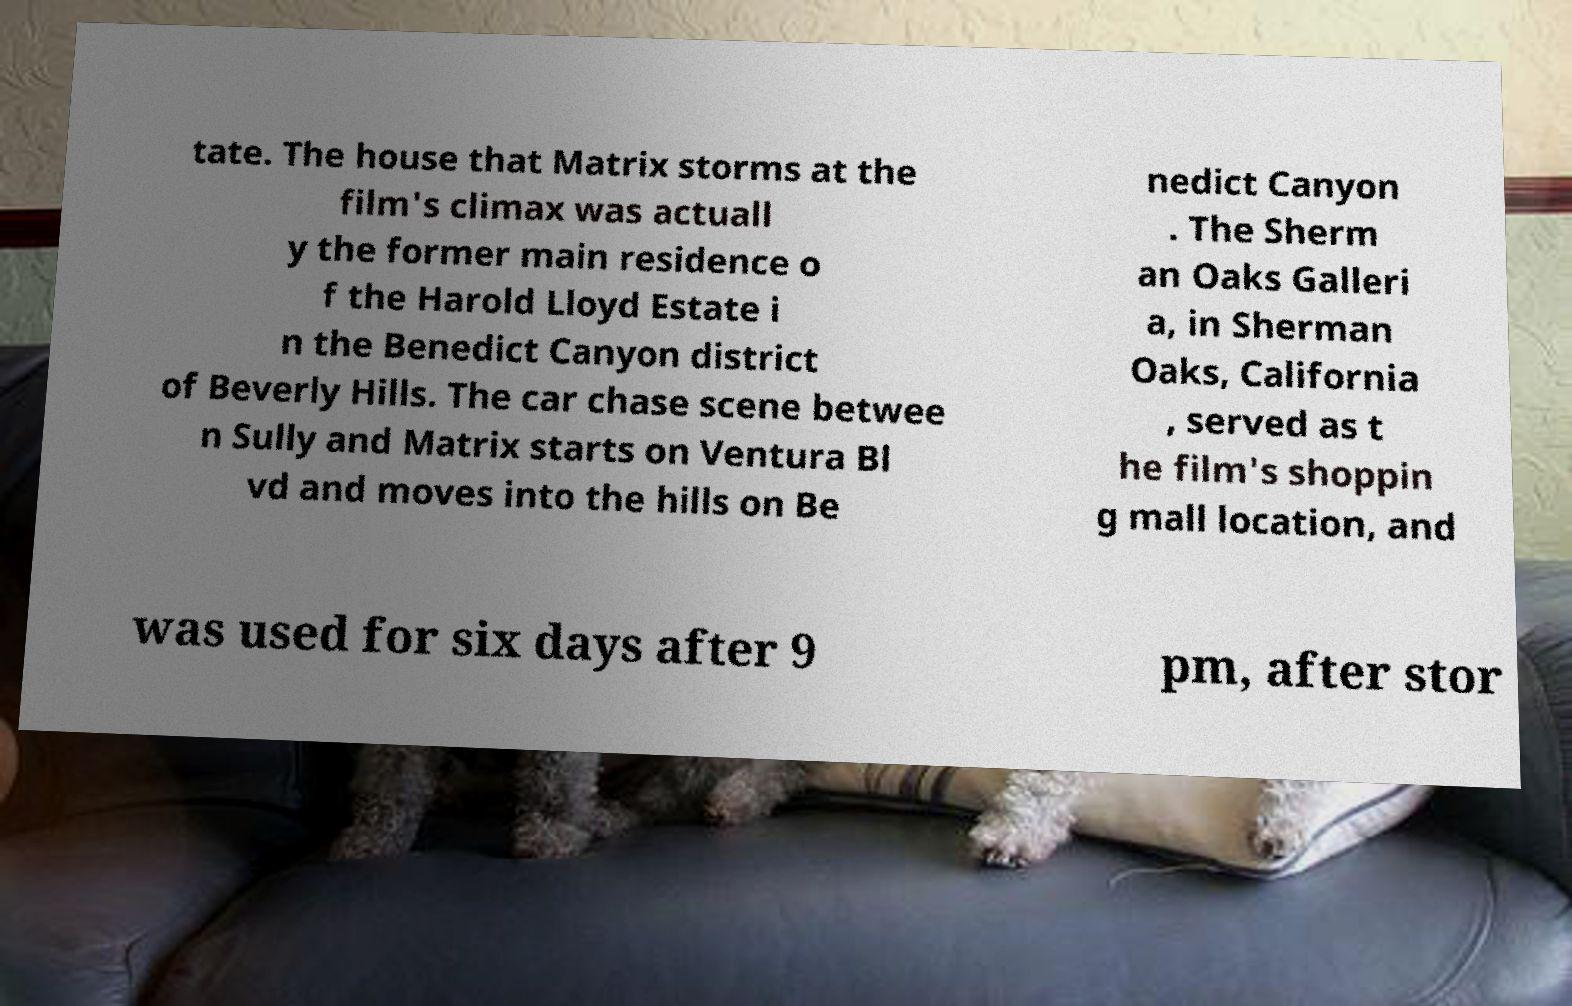Can you accurately transcribe the text from the provided image for me? tate. The house that Matrix storms at the film's climax was actuall y the former main residence o f the Harold Lloyd Estate i n the Benedict Canyon district of Beverly Hills. The car chase scene betwee n Sully and Matrix starts on Ventura Bl vd and moves into the hills on Be nedict Canyon . The Sherm an Oaks Galleri a, in Sherman Oaks, California , served as t he film's shoppin g mall location, and was used for six days after 9 pm, after stor 